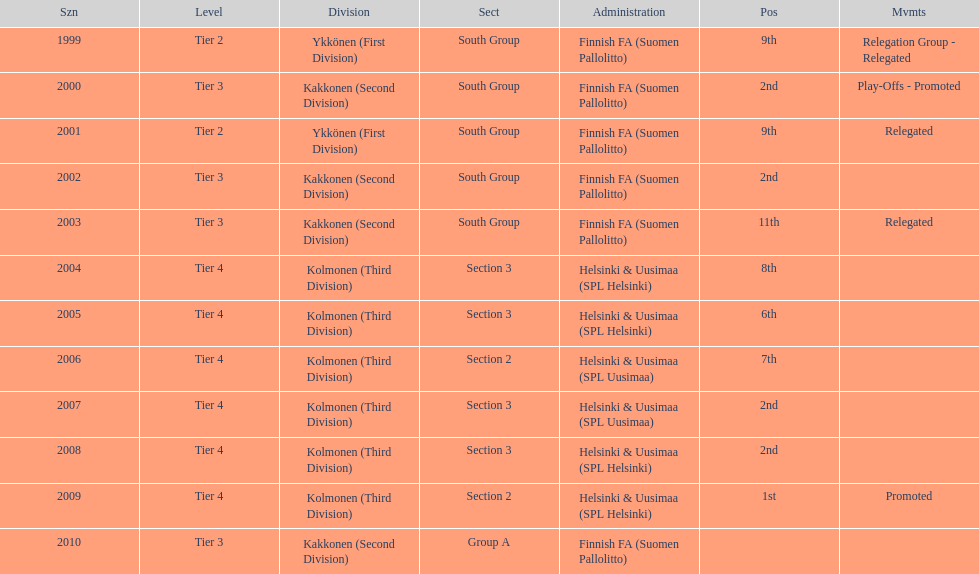What division were they in the most, section 3 or 2? 3. 